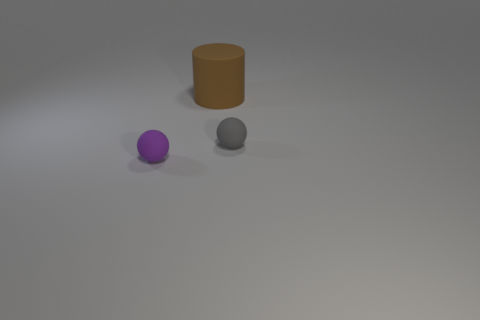Are the object that is to the right of the big rubber cylinder and the big cylinder made of the same material?
Provide a short and direct response. Yes. There is another small object that is the same shape as the purple object; what is its color?
Keep it short and to the point. Gray. Are there any other things that have the same shape as the large brown object?
Make the answer very short. No. Are there the same number of tiny gray matte spheres to the left of the large matte thing and big cyan matte objects?
Offer a terse response. Yes. There is a large thing; are there any purple matte things left of it?
Your answer should be compact. Yes. There is a matte thing in front of the small ball to the right of the tiny object on the left side of the large brown matte cylinder; what size is it?
Your response must be concise. Small. There is a tiny object that is in front of the gray sphere; is its shape the same as the thing that is right of the matte cylinder?
Provide a succinct answer. Yes. What size is the purple matte thing that is the same shape as the gray matte object?
Make the answer very short. Small. What number of spheres are the same material as the cylinder?
Ensure brevity in your answer.  2. What is the material of the small purple thing?
Keep it short and to the point. Rubber. 